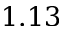Convert formula to latex. <formula><loc_0><loc_0><loc_500><loc_500>1 . 1 3</formula> 